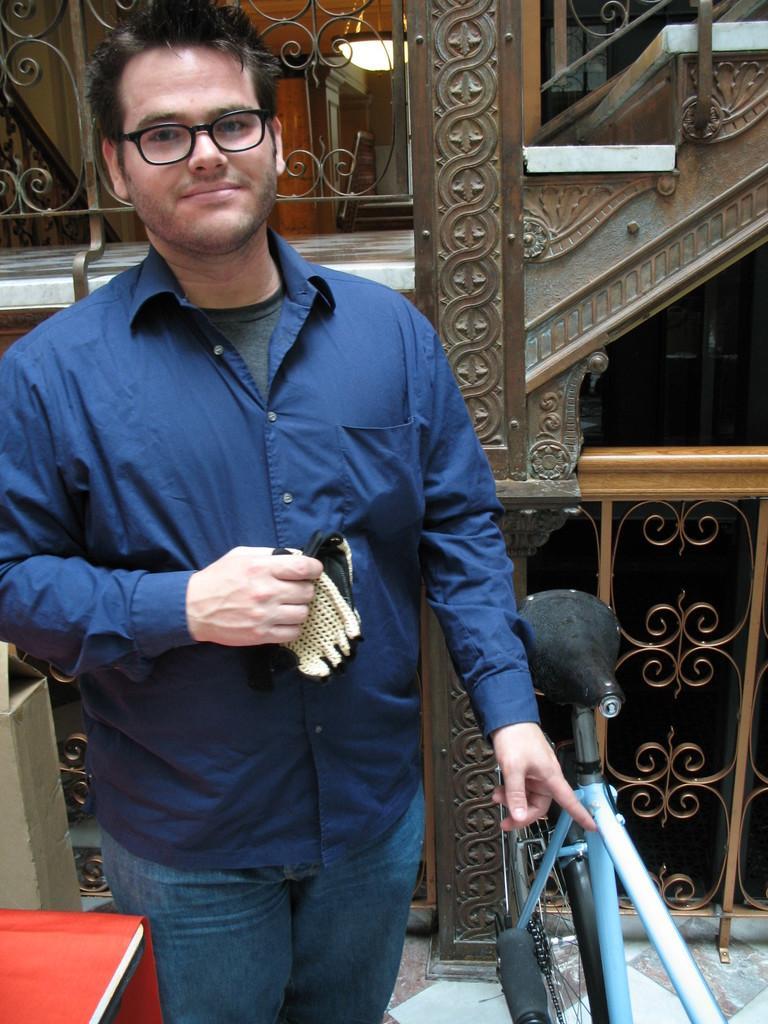Please provide a concise description of this image. In this image we can see a person holding gloves in his hand is standing beside a bicycle placed on the ground. On the left side of the image we can see a cloth on a table and a cardboard box. In the background, we can see railing, staircase and a lamp. 